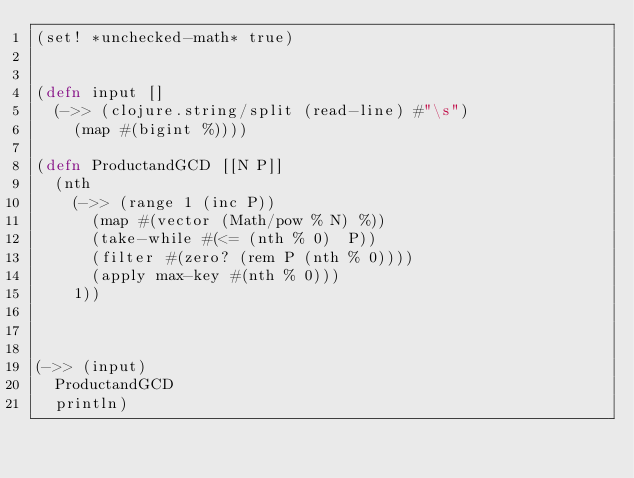Convert code to text. <code><loc_0><loc_0><loc_500><loc_500><_Clojure_>(set! *unchecked-math* true)


(defn input []
  (->> (clojure.string/split (read-line) #"\s")
    (map #(bigint %))))

(defn ProductandGCD [[N P]]
  (nth
    (->> (range 1 (inc P))
      (map #(vector (Math/pow % N) %))
      (take-while #(<= (nth % 0)  P))
      (filter #(zero? (rem P (nth % 0))))
      (apply max-key #(nth % 0)))
    1))



(->> (input)
  ProductandGCD
  println)</code> 